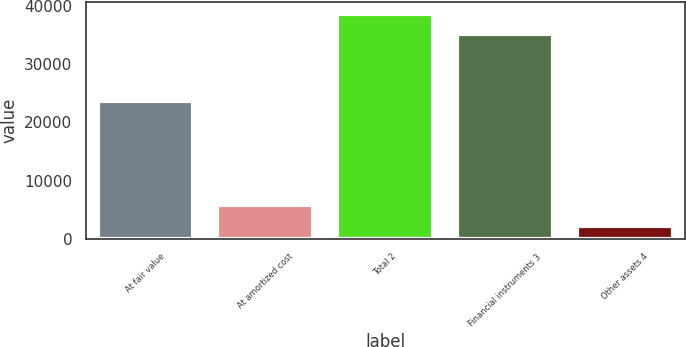Convert chart. <chart><loc_0><loc_0><loc_500><loc_500><bar_chart><fcel>At fair value<fcel>At amortized cost<fcel>Total 2<fcel>Financial instruments 3<fcel>Other assets 4<nl><fcel>23659<fcel>5752.4<fcel>38636.4<fcel>35124<fcel>2240<nl></chart> 